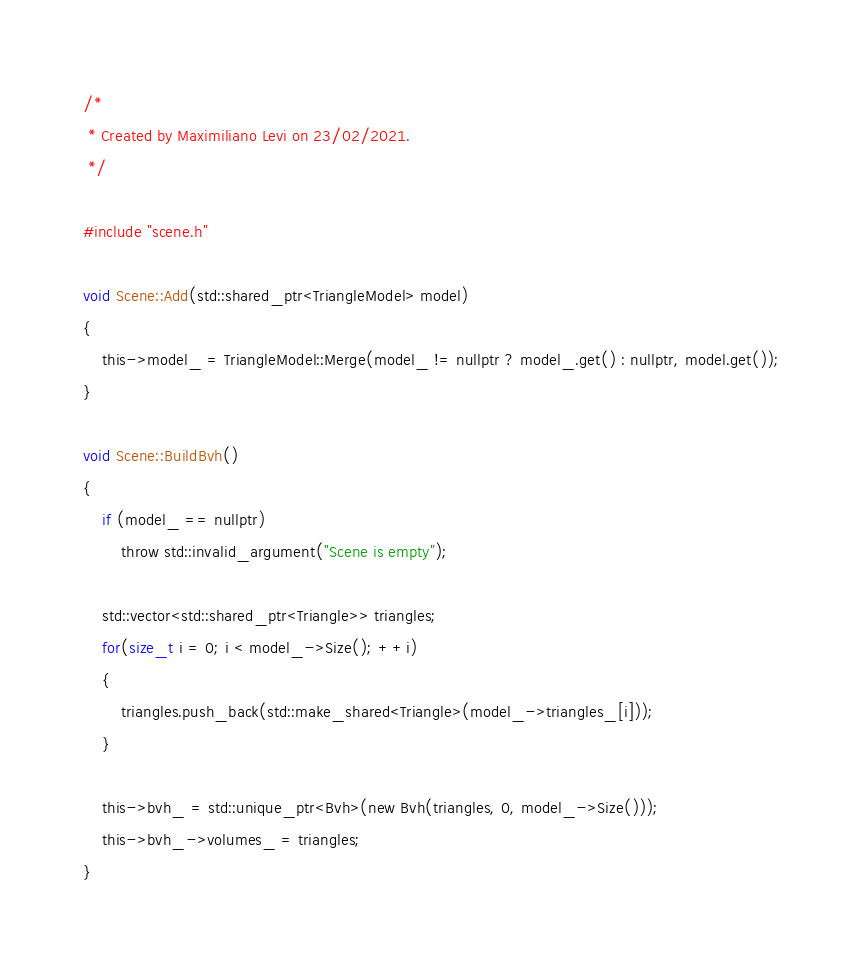Convert code to text. <code><loc_0><loc_0><loc_500><loc_500><_Cuda_>/*
 * Created by Maximiliano Levi on 23/02/2021.
 */

#include "scene.h"

void Scene::Add(std::shared_ptr<TriangleModel> model)
{
    this->model_ = TriangleModel::Merge(model_ != nullptr ? model_.get() : nullptr, model.get());
}

void Scene::BuildBvh()
{
    if (model_ == nullptr)
        throw std::invalid_argument("Scene is empty");

    std::vector<std::shared_ptr<Triangle>> triangles;
    for(size_t i = 0; i < model_->Size(); ++i)
    {
        triangles.push_back(std::make_shared<Triangle>(model_->triangles_[i]));
    }

    this->bvh_ = std::unique_ptr<Bvh>(new Bvh(triangles, 0, model_->Size()));
    this->bvh_->volumes_ = triangles;
}</code> 